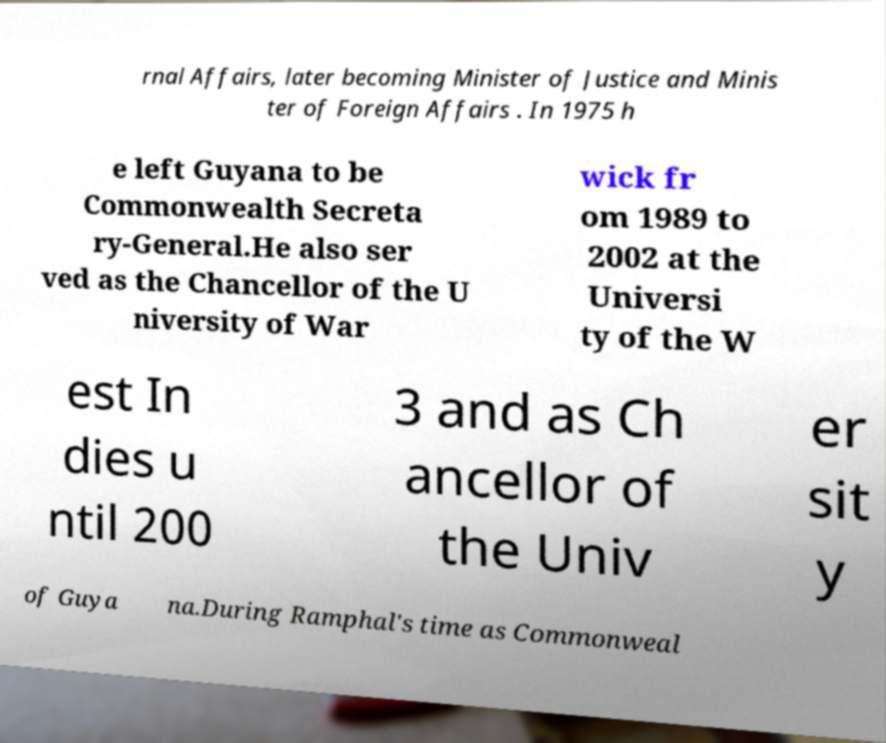Can you read and provide the text displayed in the image?This photo seems to have some interesting text. Can you extract and type it out for me? rnal Affairs, later becoming Minister of Justice and Minis ter of Foreign Affairs . In 1975 h e left Guyana to be Commonwealth Secreta ry-General.He also ser ved as the Chancellor of the U niversity of War wick fr om 1989 to 2002 at the Universi ty of the W est In dies u ntil 200 3 and as Ch ancellor of the Univ er sit y of Guya na.During Ramphal's time as Commonweal 